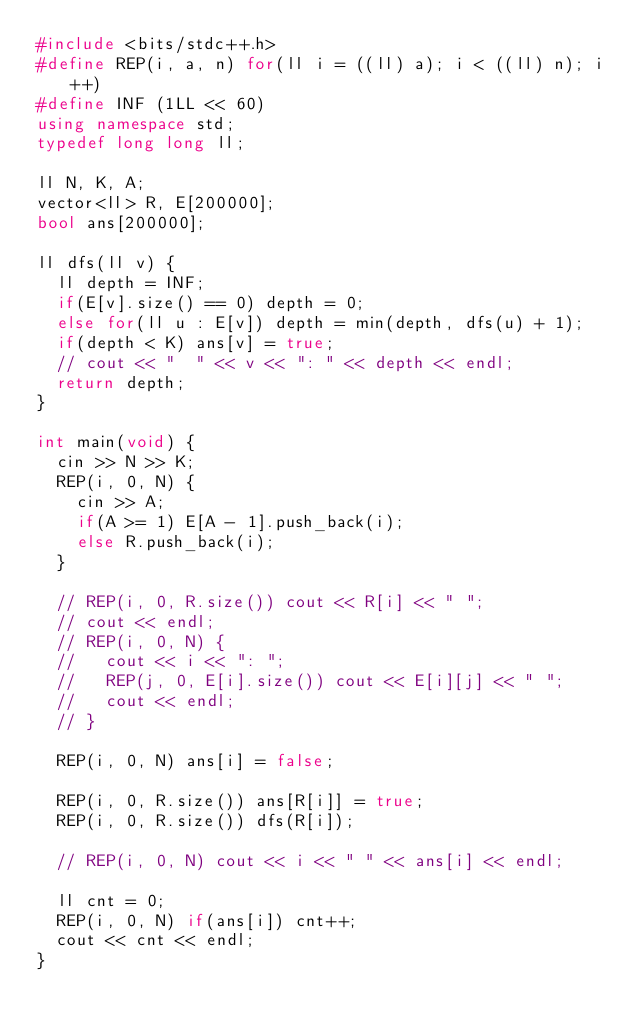Convert code to text. <code><loc_0><loc_0><loc_500><loc_500><_C++_>#include <bits/stdc++.h>
#define REP(i, a, n) for(ll i = ((ll) a); i < ((ll) n); i++)
#define INF (1LL << 60)
using namespace std;
typedef long long ll;

ll N, K, A;
vector<ll> R, E[200000];
bool ans[200000];

ll dfs(ll v) {
  ll depth = INF;
  if(E[v].size() == 0) depth = 0;
  else for(ll u : E[v]) depth = min(depth, dfs(u) + 1);
  if(depth < K) ans[v] = true;
  // cout << "  " << v << ": " << depth << endl;
  return depth;
}

int main(void) {
  cin >> N >> K;
  REP(i, 0, N) {
    cin >> A;
    if(A >= 1) E[A - 1].push_back(i);
    else R.push_back(i);
  }

  // REP(i, 0, R.size()) cout << R[i] << " ";
  // cout << endl;
  // REP(i, 0, N) {
  //   cout << i << ": ";
  //   REP(j, 0, E[i].size()) cout << E[i][j] << " ";
  //   cout << endl;
  // }

  REP(i, 0, N) ans[i] = false;

  REP(i, 0, R.size()) ans[R[i]] = true;
  REP(i, 0, R.size()) dfs(R[i]);

  // REP(i, 0, N) cout << i << " " << ans[i] << endl;

  ll cnt = 0;
  REP(i, 0, N) if(ans[i]) cnt++;
  cout << cnt << endl;
}</code> 